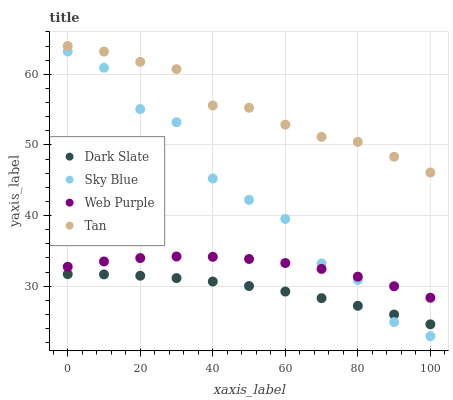Does Dark Slate have the minimum area under the curve?
Answer yes or no. Yes. Does Tan have the maximum area under the curve?
Answer yes or no. Yes. Does Web Purple have the minimum area under the curve?
Answer yes or no. No. Does Web Purple have the maximum area under the curve?
Answer yes or no. No. Is Dark Slate the smoothest?
Answer yes or no. Yes. Is Sky Blue the roughest?
Answer yes or no. Yes. Is Web Purple the smoothest?
Answer yes or no. No. Is Web Purple the roughest?
Answer yes or no. No. Does Sky Blue have the lowest value?
Answer yes or no. Yes. Does Web Purple have the lowest value?
Answer yes or no. No. Does Tan have the highest value?
Answer yes or no. Yes. Does Web Purple have the highest value?
Answer yes or no. No. Is Dark Slate less than Tan?
Answer yes or no. Yes. Is Tan greater than Web Purple?
Answer yes or no. Yes. Does Sky Blue intersect Dark Slate?
Answer yes or no. Yes. Is Sky Blue less than Dark Slate?
Answer yes or no. No. Is Sky Blue greater than Dark Slate?
Answer yes or no. No. Does Dark Slate intersect Tan?
Answer yes or no. No. 